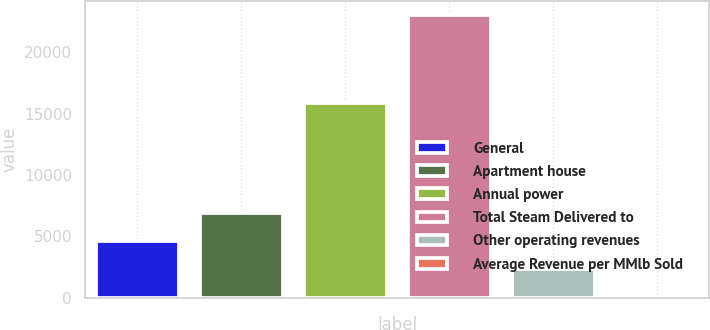Convert chart. <chart><loc_0><loc_0><loc_500><loc_500><bar_chart><fcel>General<fcel>Apartment house<fcel>Annual power<fcel>Total Steam Delivered to<fcel>Other operating revenues<fcel>Average Revenue per MMlb Sold<nl><fcel>4626.8<fcel>6925.45<fcel>15848<fcel>23016<fcel>2328.15<fcel>29.5<nl></chart> 